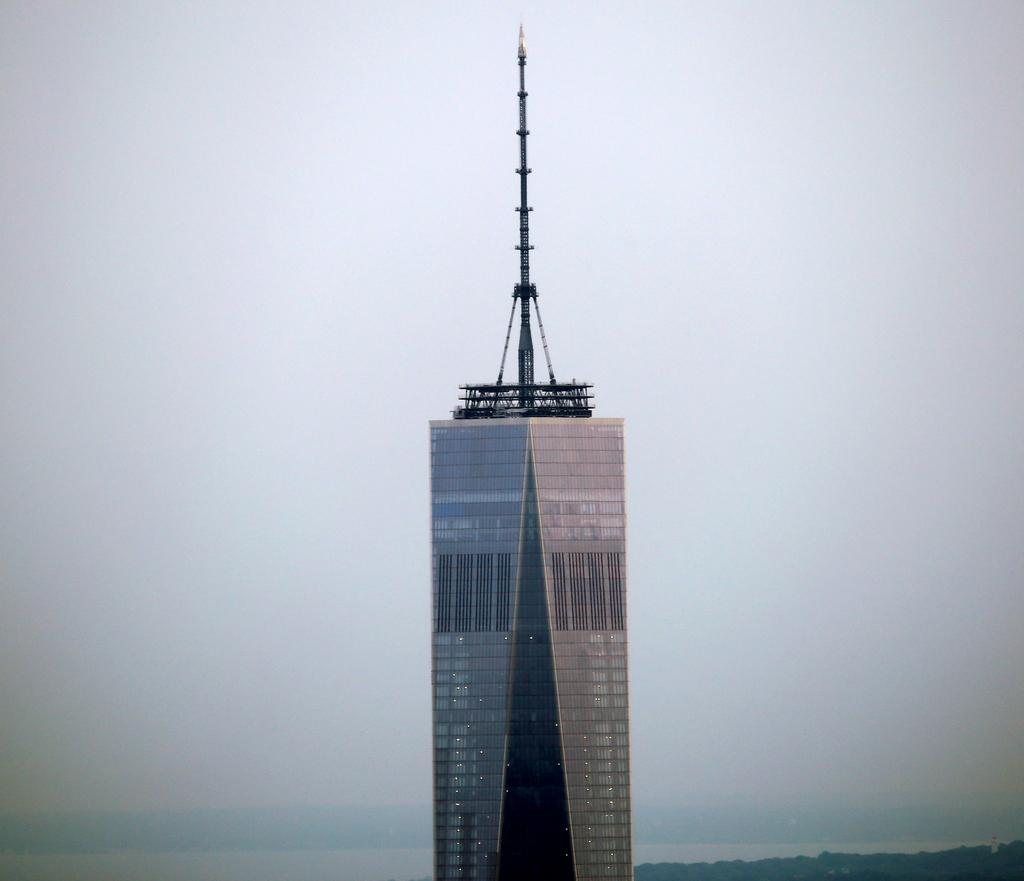What structure is visible in the image? There is a building in the image. What is the condition of the sky in the image? The sky is cloudy in the image. What type of brick is being used to construct the building in the image? There is no information about the type of brick used in the construction of the building in the image. Can you see a donkey in the image? There is no donkey present in the image. 